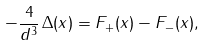<formula> <loc_0><loc_0><loc_500><loc_500>- \frac { 4 } { d ^ { 3 } } \, \Delta ( x ) = F _ { + } ( x ) - F _ { - } ( x ) ,</formula> 